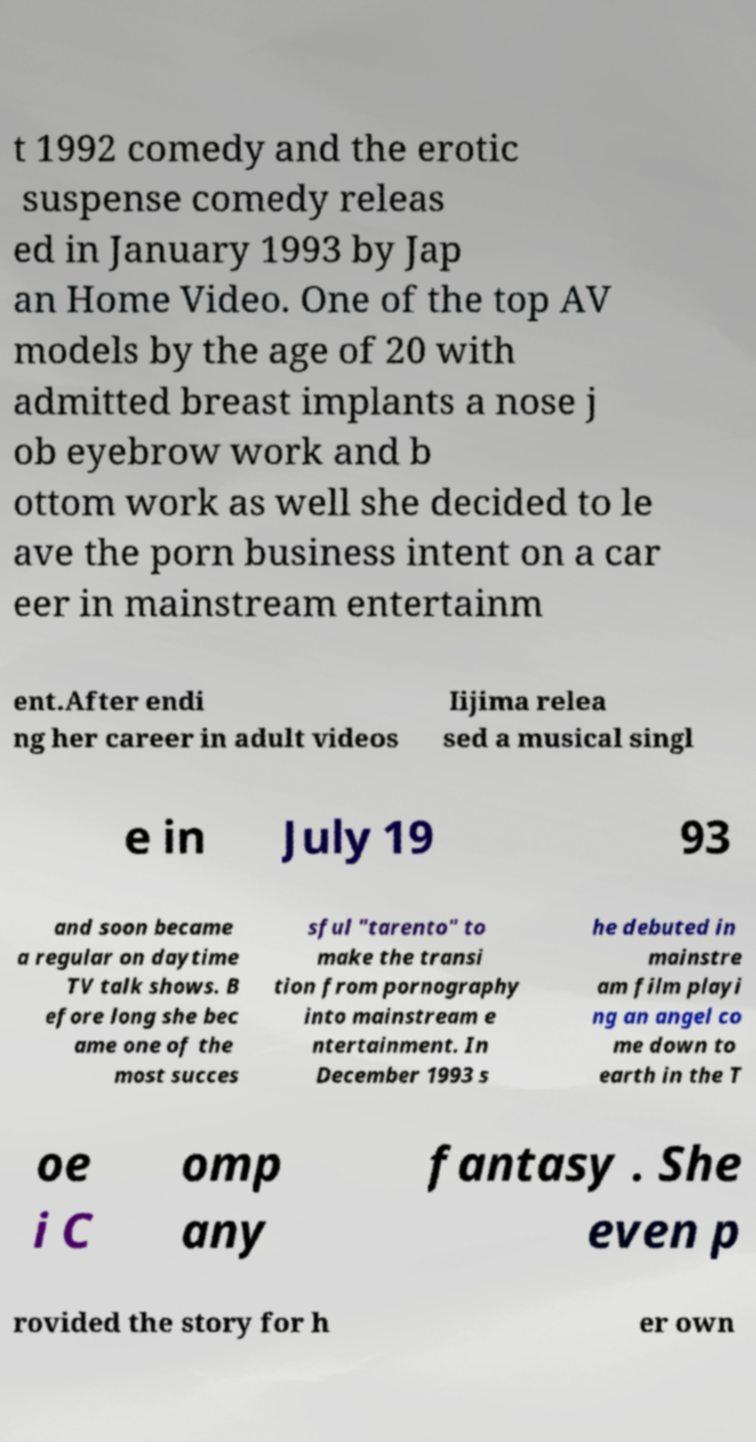Can you read and provide the text displayed in the image?This photo seems to have some interesting text. Can you extract and type it out for me? t 1992 comedy and the erotic suspense comedy releas ed in January 1993 by Jap an Home Video. One of the top AV models by the age of 20 with admitted breast implants a nose j ob eyebrow work and b ottom work as well she decided to le ave the porn business intent on a car eer in mainstream entertainm ent.After endi ng her career in adult videos Iijima relea sed a musical singl e in July 19 93 and soon became a regular on daytime TV talk shows. B efore long she bec ame one of the most succes sful "tarento" to make the transi tion from pornography into mainstream e ntertainment. In December 1993 s he debuted in mainstre am film playi ng an angel co me down to earth in the T oe i C omp any fantasy . She even p rovided the story for h er own 